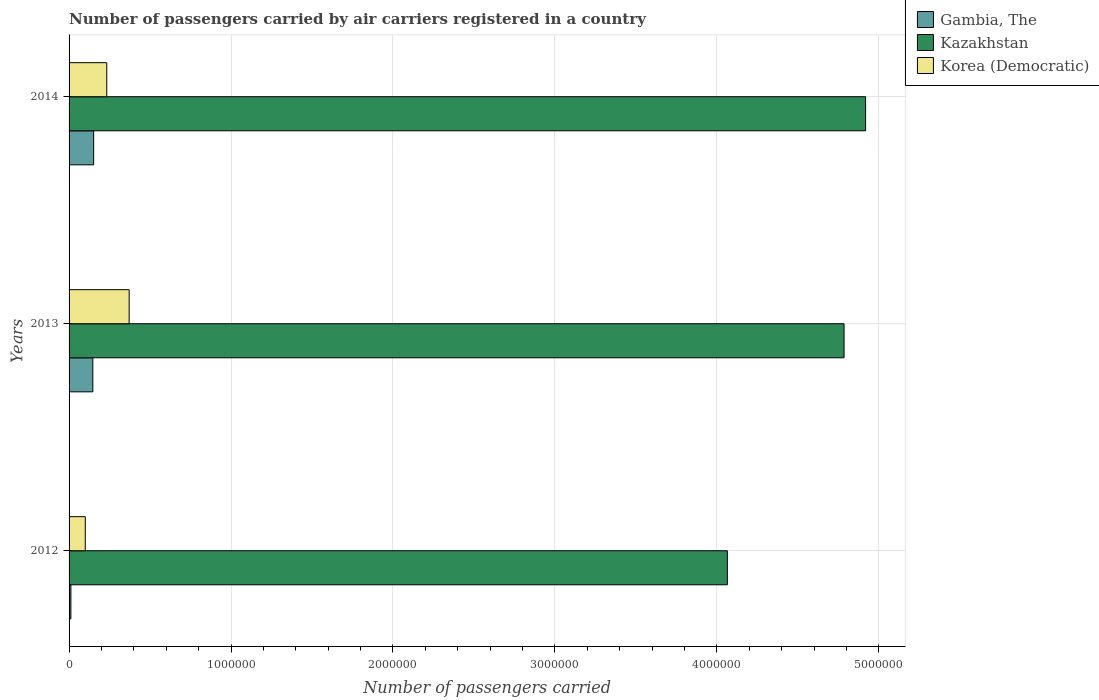How many different coloured bars are there?
Give a very brief answer. 3. Are the number of bars per tick equal to the number of legend labels?
Provide a succinct answer. Yes. What is the label of the 2nd group of bars from the top?
Offer a very short reply. 2013. In how many cases, is the number of bars for a given year not equal to the number of legend labels?
Offer a terse response. 0. What is the number of passengers carried by air carriers in Korea (Democratic) in 2012?
Give a very brief answer. 1.00e+05. Across all years, what is the maximum number of passengers carried by air carriers in Gambia, The?
Make the answer very short. 1.52e+05. Across all years, what is the minimum number of passengers carried by air carriers in Kazakhstan?
Provide a short and direct response. 4.06e+06. What is the total number of passengers carried by air carriers in Gambia, The in the graph?
Offer a very short reply. 3.10e+05. What is the difference between the number of passengers carried by air carriers in Gambia, The in 2013 and that in 2014?
Give a very brief answer. -4990.75. What is the difference between the number of passengers carried by air carriers in Gambia, The in 2014 and the number of passengers carried by air carriers in Kazakhstan in 2012?
Your answer should be compact. -3.91e+06. What is the average number of passengers carried by air carriers in Gambia, The per year?
Make the answer very short. 1.03e+05. In the year 2014, what is the difference between the number of passengers carried by air carriers in Gambia, The and number of passengers carried by air carriers in Kazakhstan?
Provide a short and direct response. -4.77e+06. What is the ratio of the number of passengers carried by air carriers in Kazakhstan in 2012 to that in 2014?
Offer a very short reply. 0.83. Is the difference between the number of passengers carried by air carriers in Gambia, The in 2012 and 2014 greater than the difference between the number of passengers carried by air carriers in Kazakhstan in 2012 and 2014?
Keep it short and to the point. Yes. What is the difference between the highest and the second highest number of passengers carried by air carriers in Gambia, The?
Your answer should be very brief. 4990.75. What is the difference between the highest and the lowest number of passengers carried by air carriers in Gambia, The?
Make the answer very short. 1.40e+05. In how many years, is the number of passengers carried by air carriers in Kazakhstan greater than the average number of passengers carried by air carriers in Kazakhstan taken over all years?
Keep it short and to the point. 2. What does the 1st bar from the top in 2012 represents?
Offer a very short reply. Korea (Democratic). What does the 3rd bar from the bottom in 2013 represents?
Give a very brief answer. Korea (Democratic). Is it the case that in every year, the sum of the number of passengers carried by air carriers in Korea (Democratic) and number of passengers carried by air carriers in Gambia, The is greater than the number of passengers carried by air carriers in Kazakhstan?
Keep it short and to the point. No. How many bars are there?
Make the answer very short. 9. Are all the bars in the graph horizontal?
Give a very brief answer. Yes. How many years are there in the graph?
Your answer should be compact. 3. Where does the legend appear in the graph?
Offer a terse response. Top right. How many legend labels are there?
Give a very brief answer. 3. How are the legend labels stacked?
Provide a succinct answer. Vertical. What is the title of the graph?
Offer a very short reply. Number of passengers carried by air carriers registered in a country. What is the label or title of the X-axis?
Provide a short and direct response. Number of passengers carried. What is the Number of passengers carried of Gambia, The in 2012?
Your response must be concise. 1.13e+04. What is the Number of passengers carried of Kazakhstan in 2012?
Provide a short and direct response. 4.06e+06. What is the Number of passengers carried of Korea (Democratic) in 2012?
Ensure brevity in your answer.  1.00e+05. What is the Number of passengers carried of Gambia, The in 2013?
Give a very brief answer. 1.47e+05. What is the Number of passengers carried in Kazakhstan in 2013?
Your response must be concise. 4.79e+06. What is the Number of passengers carried of Korea (Democratic) in 2013?
Ensure brevity in your answer.  3.71e+05. What is the Number of passengers carried of Gambia, The in 2014?
Your answer should be very brief. 1.52e+05. What is the Number of passengers carried in Kazakhstan in 2014?
Provide a succinct answer. 4.92e+06. What is the Number of passengers carried of Korea (Democratic) in 2014?
Ensure brevity in your answer.  2.33e+05. Across all years, what is the maximum Number of passengers carried in Gambia, The?
Your answer should be compact. 1.52e+05. Across all years, what is the maximum Number of passengers carried in Kazakhstan?
Make the answer very short. 4.92e+06. Across all years, what is the maximum Number of passengers carried of Korea (Democratic)?
Provide a succinct answer. 3.71e+05. Across all years, what is the minimum Number of passengers carried of Gambia, The?
Keep it short and to the point. 1.13e+04. Across all years, what is the minimum Number of passengers carried in Kazakhstan?
Provide a short and direct response. 4.06e+06. Across all years, what is the minimum Number of passengers carried in Korea (Democratic)?
Your response must be concise. 1.00e+05. What is the total Number of passengers carried in Gambia, The in the graph?
Keep it short and to the point. 3.10e+05. What is the total Number of passengers carried of Kazakhstan in the graph?
Give a very brief answer. 1.38e+07. What is the total Number of passengers carried of Korea (Democratic) in the graph?
Ensure brevity in your answer.  7.04e+05. What is the difference between the Number of passengers carried of Gambia, The in 2012 and that in 2013?
Keep it short and to the point. -1.36e+05. What is the difference between the Number of passengers carried of Kazakhstan in 2012 and that in 2013?
Your answer should be very brief. -7.21e+05. What is the difference between the Number of passengers carried of Korea (Democratic) in 2012 and that in 2013?
Provide a succinct answer. -2.71e+05. What is the difference between the Number of passengers carried in Gambia, The in 2012 and that in 2014?
Provide a short and direct response. -1.40e+05. What is the difference between the Number of passengers carried in Kazakhstan in 2012 and that in 2014?
Your answer should be very brief. -8.54e+05. What is the difference between the Number of passengers carried of Korea (Democratic) in 2012 and that in 2014?
Give a very brief answer. -1.33e+05. What is the difference between the Number of passengers carried of Gambia, The in 2013 and that in 2014?
Your answer should be compact. -4990.75. What is the difference between the Number of passengers carried in Kazakhstan in 2013 and that in 2014?
Offer a very short reply. -1.33e+05. What is the difference between the Number of passengers carried in Korea (Democratic) in 2013 and that in 2014?
Keep it short and to the point. 1.38e+05. What is the difference between the Number of passengers carried in Gambia, The in 2012 and the Number of passengers carried in Kazakhstan in 2013?
Keep it short and to the point. -4.77e+06. What is the difference between the Number of passengers carried in Gambia, The in 2012 and the Number of passengers carried in Korea (Democratic) in 2013?
Your answer should be very brief. -3.60e+05. What is the difference between the Number of passengers carried in Kazakhstan in 2012 and the Number of passengers carried in Korea (Democratic) in 2013?
Give a very brief answer. 3.69e+06. What is the difference between the Number of passengers carried of Gambia, The in 2012 and the Number of passengers carried of Kazakhstan in 2014?
Keep it short and to the point. -4.91e+06. What is the difference between the Number of passengers carried of Gambia, The in 2012 and the Number of passengers carried of Korea (Democratic) in 2014?
Give a very brief answer. -2.21e+05. What is the difference between the Number of passengers carried of Kazakhstan in 2012 and the Number of passengers carried of Korea (Democratic) in 2014?
Your answer should be compact. 3.83e+06. What is the difference between the Number of passengers carried of Gambia, The in 2013 and the Number of passengers carried of Kazakhstan in 2014?
Provide a succinct answer. -4.77e+06. What is the difference between the Number of passengers carried of Gambia, The in 2013 and the Number of passengers carried of Korea (Democratic) in 2014?
Your answer should be compact. -8.59e+04. What is the difference between the Number of passengers carried of Kazakhstan in 2013 and the Number of passengers carried of Korea (Democratic) in 2014?
Give a very brief answer. 4.55e+06. What is the average Number of passengers carried of Gambia, The per year?
Keep it short and to the point. 1.03e+05. What is the average Number of passengers carried in Kazakhstan per year?
Your answer should be very brief. 4.59e+06. What is the average Number of passengers carried of Korea (Democratic) per year?
Your response must be concise. 2.35e+05. In the year 2012, what is the difference between the Number of passengers carried in Gambia, The and Number of passengers carried in Kazakhstan?
Give a very brief answer. -4.05e+06. In the year 2012, what is the difference between the Number of passengers carried in Gambia, The and Number of passengers carried in Korea (Democratic)?
Provide a short and direct response. -8.88e+04. In the year 2012, what is the difference between the Number of passengers carried of Kazakhstan and Number of passengers carried of Korea (Democratic)?
Ensure brevity in your answer.  3.96e+06. In the year 2013, what is the difference between the Number of passengers carried of Gambia, The and Number of passengers carried of Kazakhstan?
Your response must be concise. -4.64e+06. In the year 2013, what is the difference between the Number of passengers carried in Gambia, The and Number of passengers carried in Korea (Democratic)?
Give a very brief answer. -2.24e+05. In the year 2013, what is the difference between the Number of passengers carried of Kazakhstan and Number of passengers carried of Korea (Democratic)?
Ensure brevity in your answer.  4.41e+06. In the year 2014, what is the difference between the Number of passengers carried of Gambia, The and Number of passengers carried of Kazakhstan?
Your answer should be compact. -4.77e+06. In the year 2014, what is the difference between the Number of passengers carried in Gambia, The and Number of passengers carried in Korea (Democratic)?
Ensure brevity in your answer.  -8.09e+04. In the year 2014, what is the difference between the Number of passengers carried in Kazakhstan and Number of passengers carried in Korea (Democratic)?
Your response must be concise. 4.69e+06. What is the ratio of the Number of passengers carried of Gambia, The in 2012 to that in 2013?
Your response must be concise. 0.08. What is the ratio of the Number of passengers carried in Kazakhstan in 2012 to that in 2013?
Make the answer very short. 0.85. What is the ratio of the Number of passengers carried of Korea (Democratic) in 2012 to that in 2013?
Provide a short and direct response. 0.27. What is the ratio of the Number of passengers carried in Gambia, The in 2012 to that in 2014?
Give a very brief answer. 0.07. What is the ratio of the Number of passengers carried in Kazakhstan in 2012 to that in 2014?
Your answer should be very brief. 0.83. What is the ratio of the Number of passengers carried in Korea (Democratic) in 2012 to that in 2014?
Your answer should be very brief. 0.43. What is the ratio of the Number of passengers carried of Gambia, The in 2013 to that in 2014?
Offer a terse response. 0.97. What is the ratio of the Number of passengers carried of Korea (Democratic) in 2013 to that in 2014?
Provide a short and direct response. 1.59. What is the difference between the highest and the second highest Number of passengers carried of Gambia, The?
Ensure brevity in your answer.  4990.75. What is the difference between the highest and the second highest Number of passengers carried in Kazakhstan?
Your response must be concise. 1.33e+05. What is the difference between the highest and the second highest Number of passengers carried of Korea (Democratic)?
Ensure brevity in your answer.  1.38e+05. What is the difference between the highest and the lowest Number of passengers carried of Gambia, The?
Your response must be concise. 1.40e+05. What is the difference between the highest and the lowest Number of passengers carried of Kazakhstan?
Your response must be concise. 8.54e+05. What is the difference between the highest and the lowest Number of passengers carried of Korea (Democratic)?
Keep it short and to the point. 2.71e+05. 